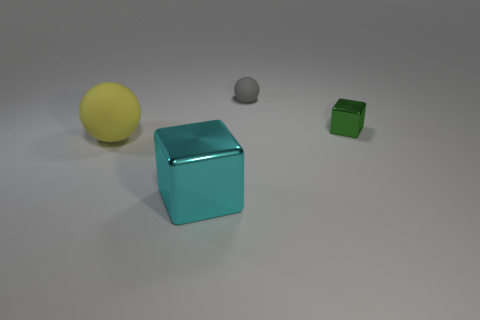What is the shape of the object that is both on the left side of the small metallic cube and on the right side of the big cyan metal object?
Offer a very short reply. Sphere. How many green objects are either metallic objects or matte spheres?
Make the answer very short. 1. There is a thing that is right of the tiny gray rubber sphere; does it have the same size as the metallic thing that is in front of the yellow matte sphere?
Your answer should be compact. No. How many objects are small green shiny objects or yellow matte cylinders?
Keep it short and to the point. 1. Are there any large gray shiny things of the same shape as the yellow thing?
Provide a succinct answer. No. Is the number of cubes less than the number of gray things?
Your answer should be very brief. No. Does the large cyan metallic thing have the same shape as the large yellow object?
Your answer should be very brief. No. What number of objects are either tiny green metallic objects or metallic blocks that are behind the big cyan metal thing?
Provide a short and direct response. 1. What number of big gray cylinders are there?
Ensure brevity in your answer.  0. Are there any cyan objects that have the same size as the yellow matte thing?
Your answer should be very brief. Yes. 